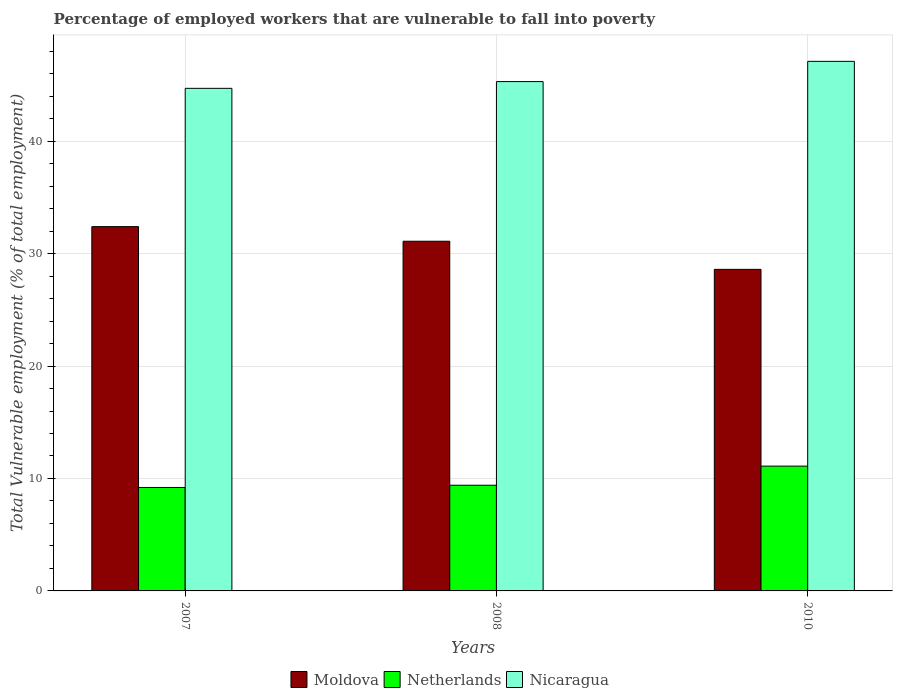How many different coloured bars are there?
Make the answer very short. 3. What is the percentage of employed workers who are vulnerable to fall into poverty in Moldova in 2007?
Give a very brief answer. 32.4. Across all years, what is the maximum percentage of employed workers who are vulnerable to fall into poverty in Moldova?
Provide a short and direct response. 32.4. Across all years, what is the minimum percentage of employed workers who are vulnerable to fall into poverty in Nicaragua?
Your answer should be very brief. 44.7. What is the total percentage of employed workers who are vulnerable to fall into poverty in Nicaragua in the graph?
Keep it short and to the point. 137.1. What is the difference between the percentage of employed workers who are vulnerable to fall into poverty in Nicaragua in 2007 and that in 2008?
Offer a very short reply. -0.6. What is the difference between the percentage of employed workers who are vulnerable to fall into poverty in Moldova in 2008 and the percentage of employed workers who are vulnerable to fall into poverty in Nicaragua in 2010?
Make the answer very short. -16. What is the average percentage of employed workers who are vulnerable to fall into poverty in Moldova per year?
Offer a very short reply. 30.7. In the year 2010, what is the difference between the percentage of employed workers who are vulnerable to fall into poverty in Nicaragua and percentage of employed workers who are vulnerable to fall into poverty in Moldova?
Offer a terse response. 18.5. What is the ratio of the percentage of employed workers who are vulnerable to fall into poverty in Moldova in 2007 to that in 2008?
Your answer should be very brief. 1.04. Is the percentage of employed workers who are vulnerable to fall into poverty in Netherlands in 2007 less than that in 2008?
Make the answer very short. Yes. What is the difference between the highest and the second highest percentage of employed workers who are vulnerable to fall into poverty in Netherlands?
Provide a short and direct response. 1.7. What is the difference between the highest and the lowest percentage of employed workers who are vulnerable to fall into poverty in Nicaragua?
Keep it short and to the point. 2.4. What does the 1st bar from the left in 2010 represents?
Your answer should be very brief. Moldova. What does the 2nd bar from the right in 2008 represents?
Make the answer very short. Netherlands. Is it the case that in every year, the sum of the percentage of employed workers who are vulnerable to fall into poverty in Nicaragua and percentage of employed workers who are vulnerable to fall into poverty in Netherlands is greater than the percentage of employed workers who are vulnerable to fall into poverty in Moldova?
Your answer should be compact. Yes. How many years are there in the graph?
Ensure brevity in your answer.  3. What is the difference between two consecutive major ticks on the Y-axis?
Make the answer very short. 10. Are the values on the major ticks of Y-axis written in scientific E-notation?
Your response must be concise. No. Where does the legend appear in the graph?
Your answer should be compact. Bottom center. How are the legend labels stacked?
Ensure brevity in your answer.  Horizontal. What is the title of the graph?
Offer a very short reply. Percentage of employed workers that are vulnerable to fall into poverty. What is the label or title of the Y-axis?
Your answer should be very brief. Total Vulnerable employment (% of total employment). What is the Total Vulnerable employment (% of total employment) in Moldova in 2007?
Provide a short and direct response. 32.4. What is the Total Vulnerable employment (% of total employment) in Netherlands in 2007?
Offer a terse response. 9.2. What is the Total Vulnerable employment (% of total employment) of Nicaragua in 2007?
Offer a very short reply. 44.7. What is the Total Vulnerable employment (% of total employment) of Moldova in 2008?
Offer a very short reply. 31.1. What is the Total Vulnerable employment (% of total employment) of Netherlands in 2008?
Ensure brevity in your answer.  9.4. What is the Total Vulnerable employment (% of total employment) of Nicaragua in 2008?
Your answer should be very brief. 45.3. What is the Total Vulnerable employment (% of total employment) in Moldova in 2010?
Provide a succinct answer. 28.6. What is the Total Vulnerable employment (% of total employment) of Netherlands in 2010?
Make the answer very short. 11.1. What is the Total Vulnerable employment (% of total employment) of Nicaragua in 2010?
Keep it short and to the point. 47.1. Across all years, what is the maximum Total Vulnerable employment (% of total employment) of Moldova?
Your answer should be compact. 32.4. Across all years, what is the maximum Total Vulnerable employment (% of total employment) in Netherlands?
Your response must be concise. 11.1. Across all years, what is the maximum Total Vulnerable employment (% of total employment) in Nicaragua?
Keep it short and to the point. 47.1. Across all years, what is the minimum Total Vulnerable employment (% of total employment) in Moldova?
Make the answer very short. 28.6. Across all years, what is the minimum Total Vulnerable employment (% of total employment) of Netherlands?
Make the answer very short. 9.2. Across all years, what is the minimum Total Vulnerable employment (% of total employment) of Nicaragua?
Keep it short and to the point. 44.7. What is the total Total Vulnerable employment (% of total employment) in Moldova in the graph?
Keep it short and to the point. 92.1. What is the total Total Vulnerable employment (% of total employment) in Netherlands in the graph?
Offer a terse response. 29.7. What is the total Total Vulnerable employment (% of total employment) of Nicaragua in the graph?
Keep it short and to the point. 137.1. What is the difference between the Total Vulnerable employment (% of total employment) in Moldova in 2007 and that in 2008?
Offer a terse response. 1.3. What is the difference between the Total Vulnerable employment (% of total employment) of Netherlands in 2007 and that in 2008?
Offer a very short reply. -0.2. What is the difference between the Total Vulnerable employment (% of total employment) of Nicaragua in 2007 and that in 2008?
Provide a succinct answer. -0.6. What is the difference between the Total Vulnerable employment (% of total employment) in Netherlands in 2007 and that in 2010?
Provide a short and direct response. -1.9. What is the difference between the Total Vulnerable employment (% of total employment) of Moldova in 2008 and that in 2010?
Your response must be concise. 2.5. What is the difference between the Total Vulnerable employment (% of total employment) of Netherlands in 2008 and that in 2010?
Your answer should be very brief. -1.7. What is the difference between the Total Vulnerable employment (% of total employment) in Nicaragua in 2008 and that in 2010?
Your answer should be very brief. -1.8. What is the difference between the Total Vulnerable employment (% of total employment) in Moldova in 2007 and the Total Vulnerable employment (% of total employment) in Nicaragua in 2008?
Provide a short and direct response. -12.9. What is the difference between the Total Vulnerable employment (% of total employment) in Netherlands in 2007 and the Total Vulnerable employment (% of total employment) in Nicaragua in 2008?
Offer a terse response. -36.1. What is the difference between the Total Vulnerable employment (% of total employment) in Moldova in 2007 and the Total Vulnerable employment (% of total employment) in Netherlands in 2010?
Offer a terse response. 21.3. What is the difference between the Total Vulnerable employment (% of total employment) in Moldova in 2007 and the Total Vulnerable employment (% of total employment) in Nicaragua in 2010?
Keep it short and to the point. -14.7. What is the difference between the Total Vulnerable employment (% of total employment) in Netherlands in 2007 and the Total Vulnerable employment (% of total employment) in Nicaragua in 2010?
Offer a terse response. -37.9. What is the difference between the Total Vulnerable employment (% of total employment) in Moldova in 2008 and the Total Vulnerable employment (% of total employment) in Netherlands in 2010?
Give a very brief answer. 20. What is the difference between the Total Vulnerable employment (% of total employment) in Moldova in 2008 and the Total Vulnerable employment (% of total employment) in Nicaragua in 2010?
Your answer should be very brief. -16. What is the difference between the Total Vulnerable employment (% of total employment) in Netherlands in 2008 and the Total Vulnerable employment (% of total employment) in Nicaragua in 2010?
Keep it short and to the point. -37.7. What is the average Total Vulnerable employment (% of total employment) of Moldova per year?
Provide a short and direct response. 30.7. What is the average Total Vulnerable employment (% of total employment) in Nicaragua per year?
Keep it short and to the point. 45.7. In the year 2007, what is the difference between the Total Vulnerable employment (% of total employment) in Moldova and Total Vulnerable employment (% of total employment) in Netherlands?
Make the answer very short. 23.2. In the year 2007, what is the difference between the Total Vulnerable employment (% of total employment) in Moldova and Total Vulnerable employment (% of total employment) in Nicaragua?
Provide a succinct answer. -12.3. In the year 2007, what is the difference between the Total Vulnerable employment (% of total employment) in Netherlands and Total Vulnerable employment (% of total employment) in Nicaragua?
Provide a short and direct response. -35.5. In the year 2008, what is the difference between the Total Vulnerable employment (% of total employment) of Moldova and Total Vulnerable employment (% of total employment) of Netherlands?
Ensure brevity in your answer.  21.7. In the year 2008, what is the difference between the Total Vulnerable employment (% of total employment) in Netherlands and Total Vulnerable employment (% of total employment) in Nicaragua?
Provide a succinct answer. -35.9. In the year 2010, what is the difference between the Total Vulnerable employment (% of total employment) in Moldova and Total Vulnerable employment (% of total employment) in Netherlands?
Your answer should be very brief. 17.5. In the year 2010, what is the difference between the Total Vulnerable employment (% of total employment) of Moldova and Total Vulnerable employment (% of total employment) of Nicaragua?
Your answer should be very brief. -18.5. In the year 2010, what is the difference between the Total Vulnerable employment (% of total employment) of Netherlands and Total Vulnerable employment (% of total employment) of Nicaragua?
Provide a short and direct response. -36. What is the ratio of the Total Vulnerable employment (% of total employment) in Moldova in 2007 to that in 2008?
Keep it short and to the point. 1.04. What is the ratio of the Total Vulnerable employment (% of total employment) in Netherlands in 2007 to that in 2008?
Offer a terse response. 0.98. What is the ratio of the Total Vulnerable employment (% of total employment) of Moldova in 2007 to that in 2010?
Make the answer very short. 1.13. What is the ratio of the Total Vulnerable employment (% of total employment) of Netherlands in 2007 to that in 2010?
Your answer should be very brief. 0.83. What is the ratio of the Total Vulnerable employment (% of total employment) of Nicaragua in 2007 to that in 2010?
Keep it short and to the point. 0.95. What is the ratio of the Total Vulnerable employment (% of total employment) of Moldova in 2008 to that in 2010?
Provide a succinct answer. 1.09. What is the ratio of the Total Vulnerable employment (% of total employment) in Netherlands in 2008 to that in 2010?
Your response must be concise. 0.85. What is the ratio of the Total Vulnerable employment (% of total employment) in Nicaragua in 2008 to that in 2010?
Keep it short and to the point. 0.96. What is the difference between the highest and the second highest Total Vulnerable employment (% of total employment) in Netherlands?
Your response must be concise. 1.7. What is the difference between the highest and the lowest Total Vulnerable employment (% of total employment) of Moldova?
Your response must be concise. 3.8. What is the difference between the highest and the lowest Total Vulnerable employment (% of total employment) in Netherlands?
Offer a terse response. 1.9. What is the difference between the highest and the lowest Total Vulnerable employment (% of total employment) in Nicaragua?
Offer a terse response. 2.4. 